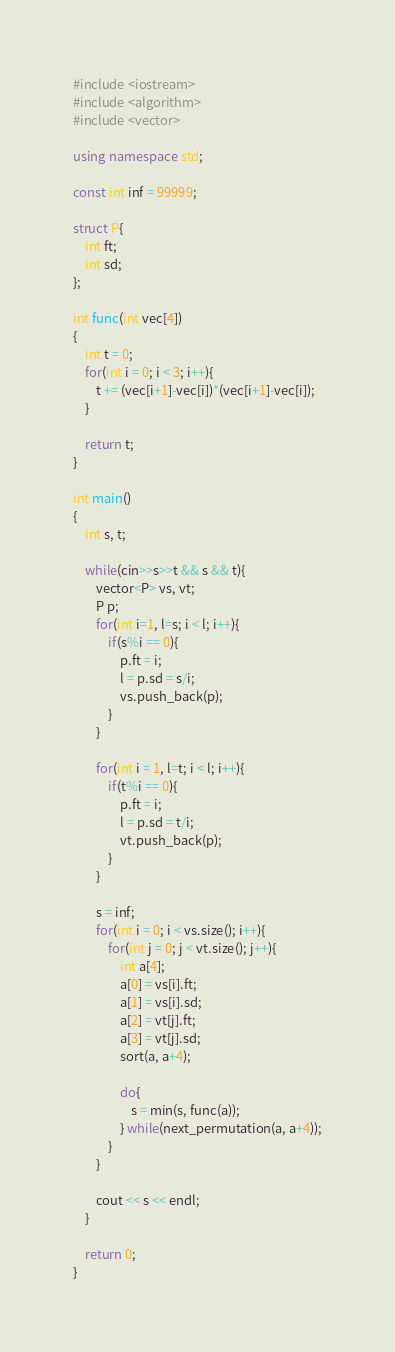Convert code to text. <code><loc_0><loc_0><loc_500><loc_500><_C++_>#include <iostream>
#include <algorithm>
#include <vector>

using namespace std;

const int inf = 99999;

struct P{
	int ft;
	int sd;
};

int func(int vec[4])
{
	int t = 0;
	for(int i = 0; i < 3; i++){
		t += (vec[i+1]-vec[i])*(vec[i+1]-vec[i]);
	}
	
	return t;
}

int main()
{
	int s, t;
	
	while(cin>>s>>t && s && t){
		vector<P> vs, vt;
		P p;
		for(int i=1, l=s; i < l; i++){
			if(s%i == 0){
				p.ft = i;
				l = p.sd = s/i;
				vs.push_back(p);
			}
		}
		
		for(int i = 1, l=t; i < l; i++){
			if(t%i == 0){
				p.ft = i;
				l = p.sd = t/i;
				vt.push_back(p);
			}
		}
		
		s = inf;
		for(int i = 0; i < vs.size(); i++){
			for(int j = 0; j < vt.size(); j++){
				int a[4];
				a[0] = vs[i].ft;
				a[1] = vs[i].sd;
				a[2] = vt[j].ft;
				a[3] = vt[j].sd;
				sort(a, a+4);

				do{
					s = min(s, func(a));
				} while(next_permutation(a, a+4));
			}
		}
		
		cout << s << endl;
	}
	
	return 0;
}</code> 